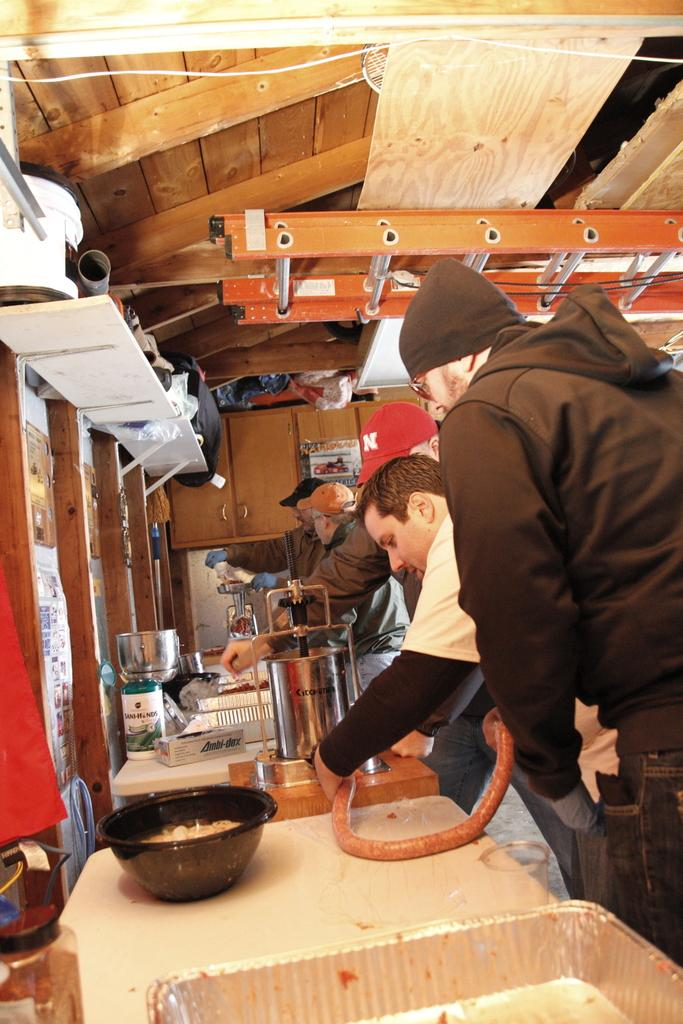What objects are on the platform in the image? There are containers and a bowl on the platform. Can you describe any other items on the platform? There are unspecified things on the platform. Who is present near the platform? There are people beside the platform. What can be seen on the wall in the image? Pictures are on the wall. Where is the poster located in the image? The poster is on a cupboard. What additional object can be seen in the image? There is a ladder in the image. Are there any fairies visible in the image? No, there are no fairies present in the image. What type of hospital is shown in the image? There is no hospital depicted in the image. 